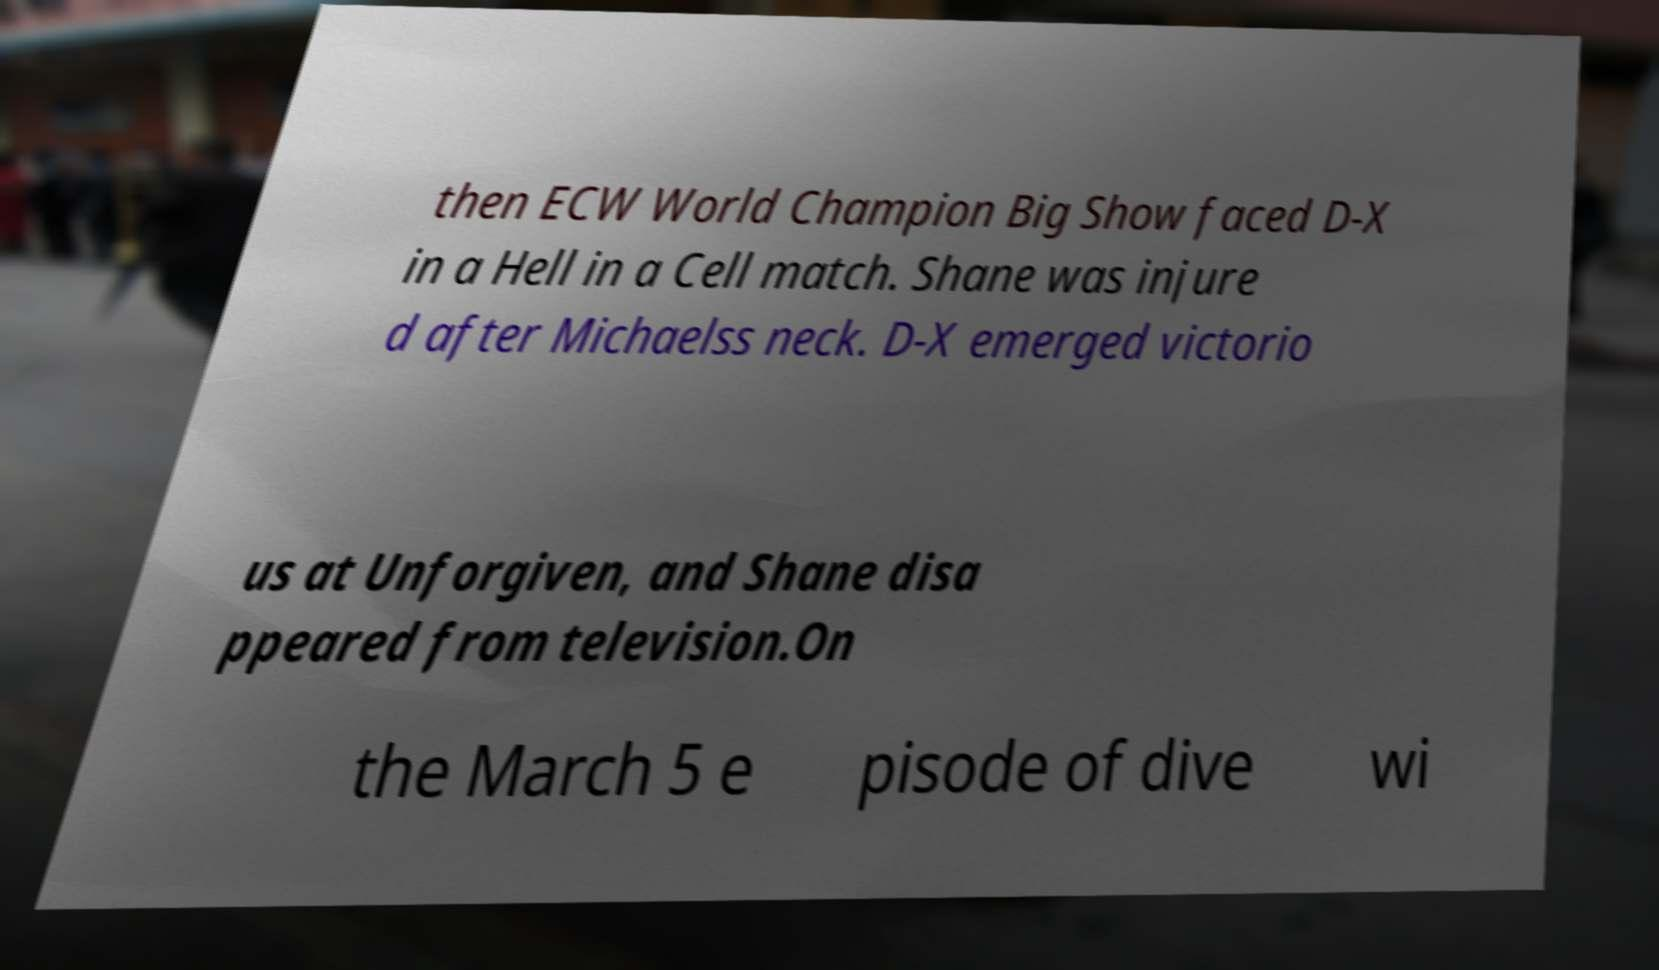What messages or text are displayed in this image? I need them in a readable, typed format. then ECW World Champion Big Show faced D-X in a Hell in a Cell match. Shane was injure d after Michaelss neck. D-X emerged victorio us at Unforgiven, and Shane disa ppeared from television.On the March 5 e pisode of dive wi 